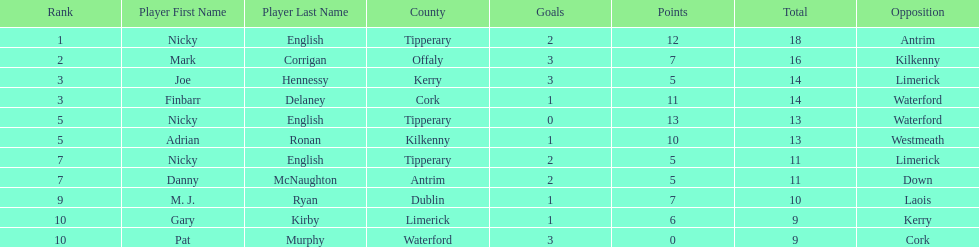If you added all the total's up, what would the number be? 138. 